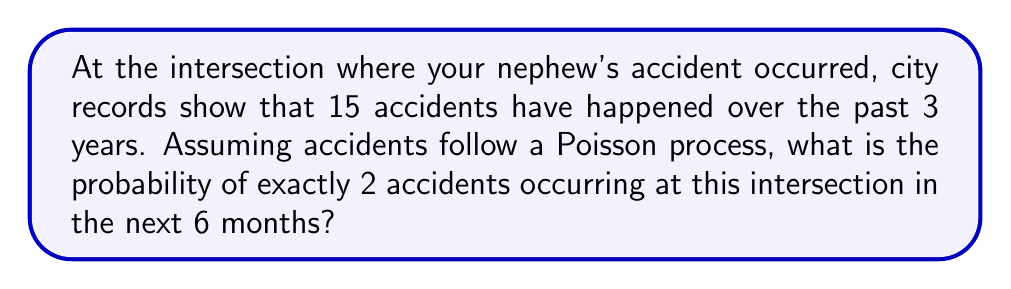What is the answer to this math problem? To solve this problem, we'll use the Poisson distribution and follow these steps:

1. Calculate the rate parameter λ:
   The rate is 15 accidents per 3 years, so for 6 months (0.5 years):
   $$ \lambda = 15 \cdot \frac{0.5}{3} = 2.5 $$

2. Use the Poisson probability mass function:
   $$ P(X = k) = \frac{e^{-\lambda} \lambda^k}{k!} $$
   where $k$ is the number of events (2 in this case)

3. Plug in the values:
   $$ P(X = 2) = \frac{e^{-2.5} 2.5^2}{2!} $$

4. Calculate:
   $$ P(X = 2) = \frac{e^{-2.5} \cdot 6.25}{2} $$
   $$ = \frac{0.0821 \cdot 6.25}{2} $$
   $$ = 0.2566 $$

5. Convert to percentage:
   $$ 0.2566 \cdot 100\% = 25.66\% $$
Answer: 25.66% 